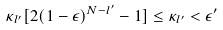<formula> <loc_0><loc_0><loc_500><loc_500>\kappa _ { l ^ { \prime } } [ 2 ( 1 - \epsilon ) ^ { N - l ^ { \prime } } - 1 ] \leq \kappa _ { l ^ { \prime } } < \epsilon ^ { \prime }</formula> 